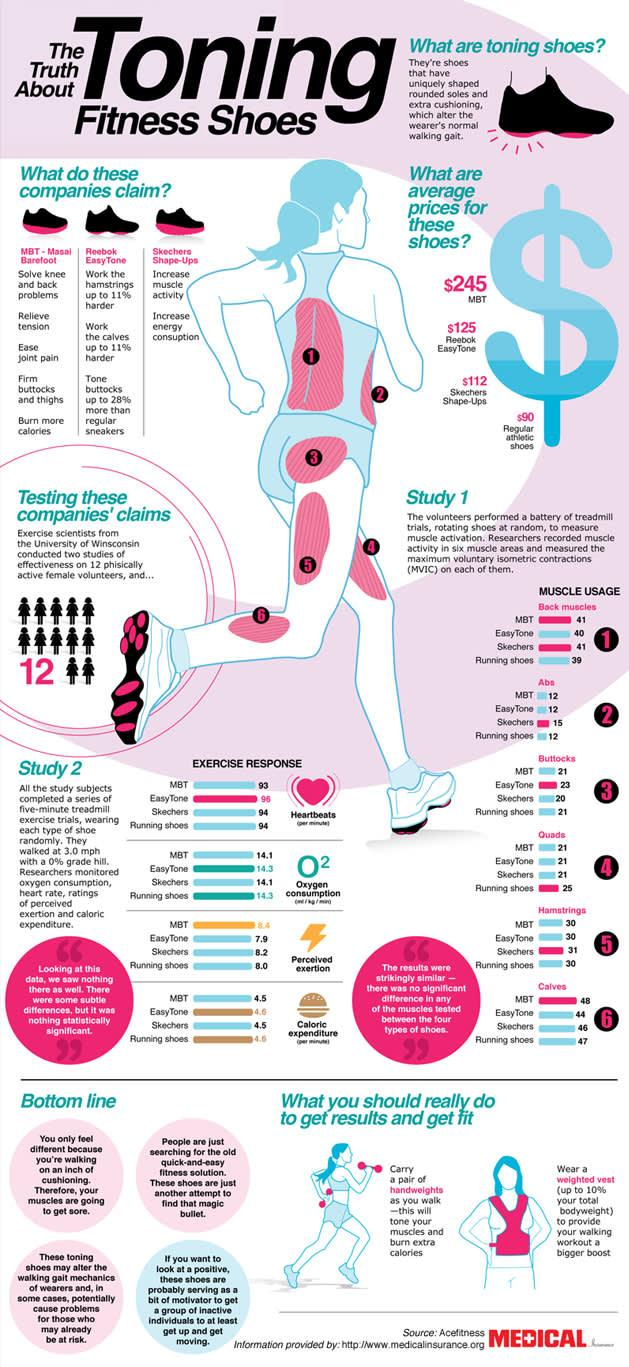Identify some key points in this picture. Reebok EasyTone claims that their toning shoes can effectively work the hamstrings and calves up to 11% harder. The brand's toning shoes that cost $245 are MBT. The image shows a female runner, and the muscles marked with the number 1 are the back muscles. The average price of Reebok Easy Tone shoes is $125. MBT, a brand of toning shoes, claims that their products can solve knee and back problems. 